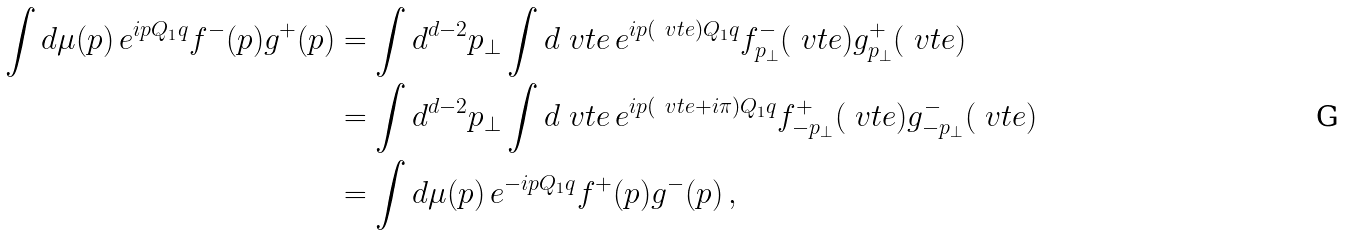<formula> <loc_0><loc_0><loc_500><loc_500>\int d \mu ( p ) \, e ^ { i p Q _ { 1 } q } f ^ { - } ( p ) g ^ { + } ( p ) & = \int d ^ { d - 2 } p _ { \perp } \int d \ v t e \, e ^ { i p ( \ v t e ) Q _ { 1 } q } f ^ { - } _ { p _ { \perp } } ( \ v t e ) g ^ { + } _ { p _ { \perp } } ( \ v t e ) \\ & = \int d ^ { d - 2 } p _ { \perp } \int d \ v t e \, e ^ { i p ( \ v t e + i \pi ) Q _ { 1 } q } f ^ { + } _ { - p _ { \perp } } ( \ v t e ) g ^ { - } _ { - p _ { \perp } } ( \ v t e ) \\ & = \int d \mu ( p ) \, e ^ { - i p Q _ { 1 } q } f ^ { + } ( p ) g ^ { - } ( p ) \, ,</formula> 